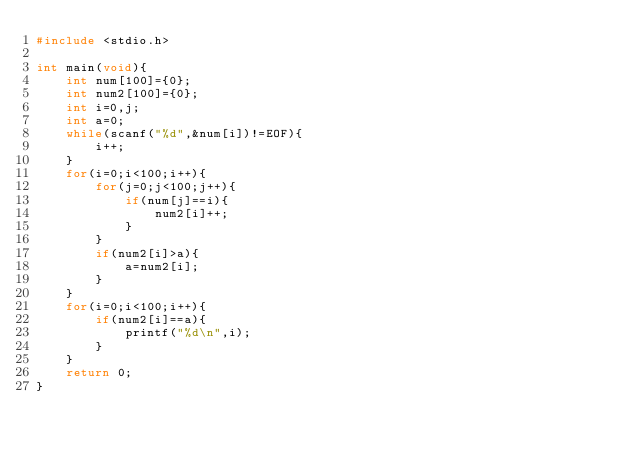<code> <loc_0><loc_0><loc_500><loc_500><_C_>#include <stdio.h>
 
int main(void){
    int num[100]={0};
    int num2[100]={0};
    int i=0,j;
    int a=0;
    while(scanf("%d",&num[i])!=EOF){
        i++;
    }
    for(i=0;i<100;i++){
        for(j=0;j<100;j++){
            if(num[j]==i){
                num2[i]++;
            }
        }
        if(num2[i]>a){
            a=num2[i];
        }
    }
    for(i=0;i<100;i++){
        if(num2[i]==a){
            printf("%d\n",i);
        }
    }
    return 0;
}</code> 